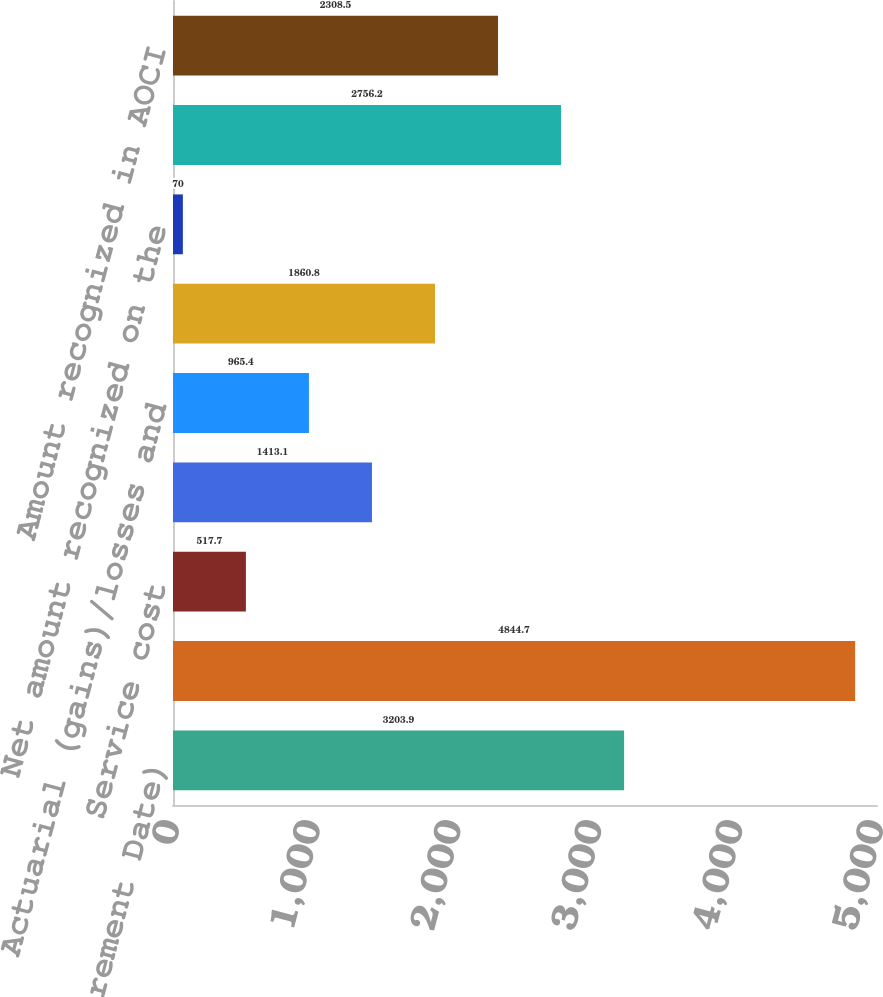<chart> <loc_0><loc_0><loc_500><loc_500><bar_chart><fcel>December 31 (Measurement Date)<fcel>Projected benefit obligation<fcel>Service cost<fcel>Interest cost<fcel>Actuarial (gains)/losses and<fcel>Benefits paid<fcel>Net amount recognized on the<fcel>Net actuarial loss<fcel>Amount recognized in AOCI<nl><fcel>3203.9<fcel>4844.7<fcel>517.7<fcel>1413.1<fcel>965.4<fcel>1860.8<fcel>70<fcel>2756.2<fcel>2308.5<nl></chart> 